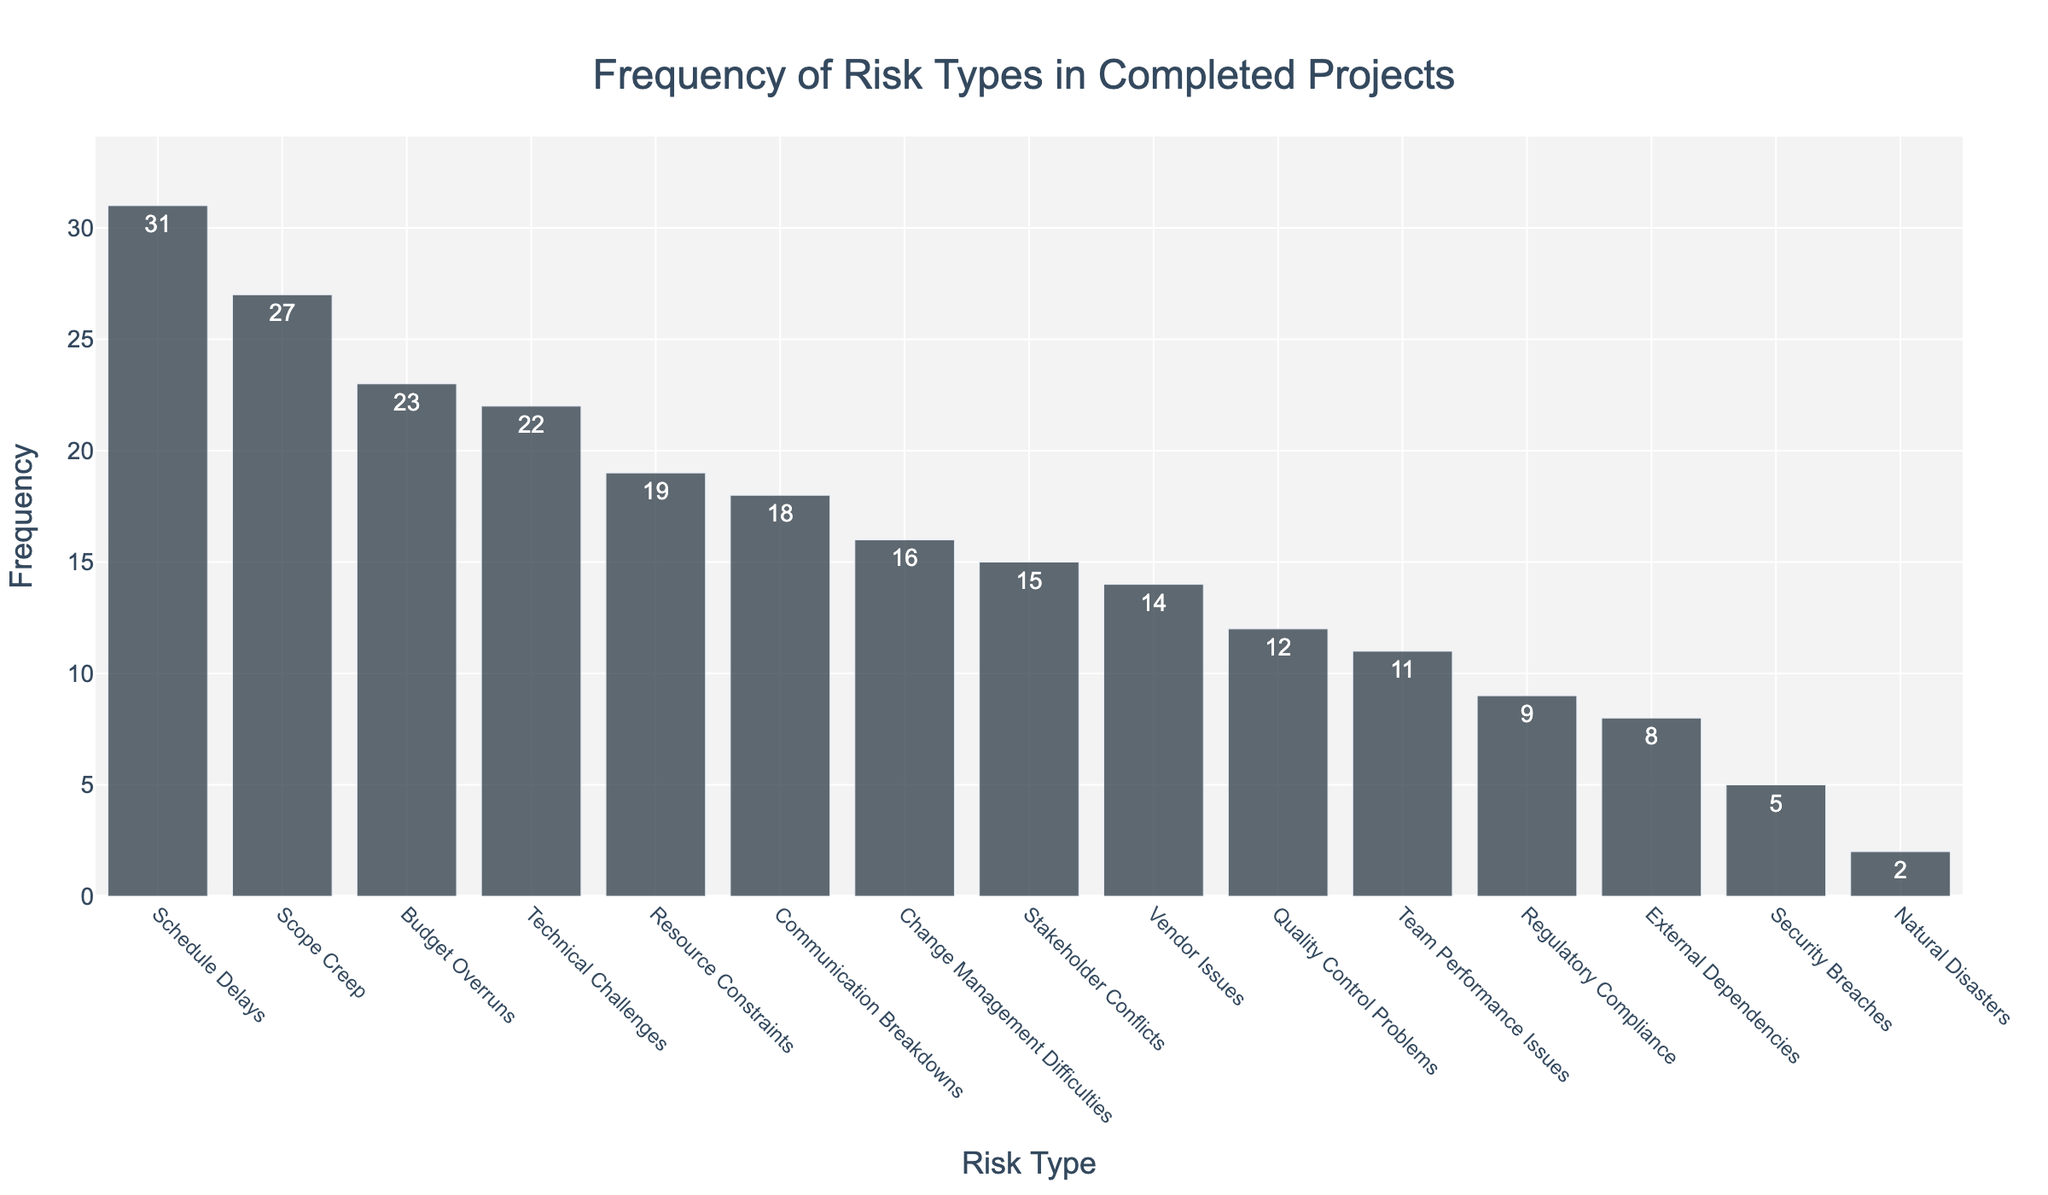How many more instances of Schedule Delays are there compared to Natural Disasters? First, find the frequency of Schedule Delays (31) and the frequency of Natural Disasters (2). Then, subtract the frequency of Natural Disasters from Schedule Delays: 31 - 2 = 29
Answer: 29 Which risk type has the third highest frequency? Sort the list by frequency in descending order. The top three frequencies are for Schedule Delays (31), Scope Creep (27), and Budget Overruns (23).
Answer: Budget Overruns What is the total frequency of the top three most common risk types? Identify the top three most common risk types: Schedule Delays (31), Scope Creep (27), and Budget Overruns (23). Sum these frequencies: 31 + 27 + 23 = 81
Answer: 81 Which risk type has the lowest frequency, and what is its value? Identify the risk type with the lowest bar, which represents Natural Disasters with a value of 2.
Answer: Natural Disasters, 2 What’s the difference in frequency between Technical Challenges and Quality Control Problems? Find the frequency of Technical Challenges (22) and Quality Control Problems (12). Subtract the frequency of Quality Control Problems from Technical Challenges: 22 - 12 = 10
Answer: 10 Summing up the frequencies of Stakeholder Conflicts and Communication Breakdowns, do they exceed that of Schedule Delays? Identify the frequencies of Stakeholder Conflicts (15) and Communication Breakdowns (18). Sum these frequencies: 15 + 18 = 33. Compare with the frequency of Schedule Delays (31). Since 33 > 31, they do exceed.
Answer: Yes Which risk type(s) have a frequency less than 10? Identify the risk types with frequencies less than 10: Regulatory Compliance (9), External Dependencies (8), Security Breaches (5), and Natural Disasters (2).
Answer: Regulatory Compliance, External Dependencies, Security Breaches, Natural Disasters What is the average frequency of the five most common risk types? Identify the top five most frequent risk types: Schedule Delays (31), Scope Creep (27), Budget Overruns (23), Technical Challenges (22), and Resource Constraints (19). Sum these frequencies: 31 + 27 + 23 + 22 + 19 = 122. Divide by 5 to find the average: 122 / 5 = 24.4
Answer: 24.4 